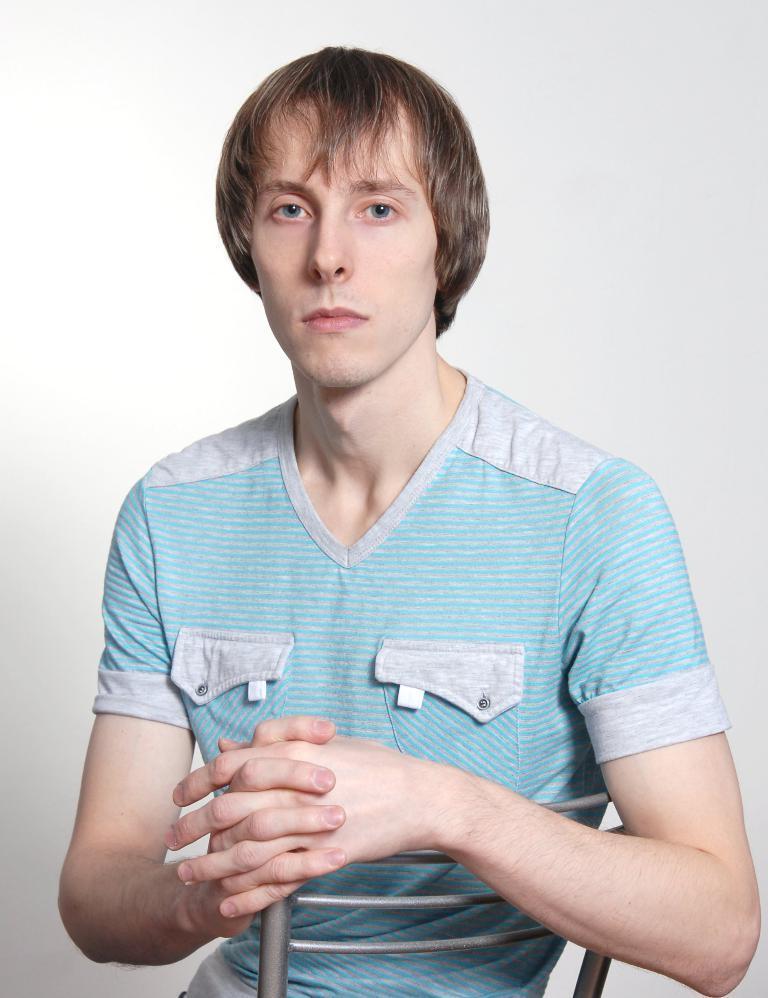Please provide a concise description of this image. In this image I can see the person sitting on the chair and the person is wearing the blue color dress. In the back I can see the white wall. 